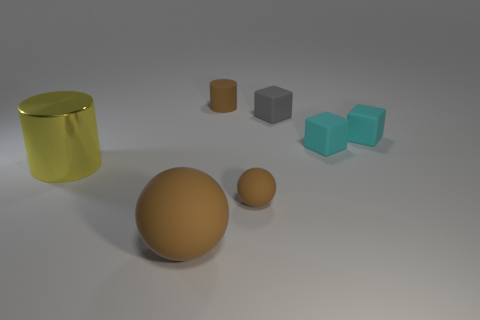Are the ball that is on the right side of the large brown ball and the tiny cylinder behind the tiny gray rubber block made of the same material?
Your answer should be very brief. Yes. There is a thing that is the same size as the shiny cylinder; what shape is it?
Give a very brief answer. Sphere. How many other objects are there of the same color as the large metal cylinder?
Your answer should be compact. 0. What color is the cylinder left of the small cylinder?
Provide a succinct answer. Yellow. What number of other things are the same material as the small gray thing?
Make the answer very short. 5. Is the number of matte spheres that are left of the small rubber sphere greater than the number of big objects to the left of the big yellow cylinder?
Offer a very short reply. Yes. How many large cylinders are on the left side of the tiny brown sphere?
Offer a terse response. 1. Is the material of the tiny ball the same as the tiny brown thing behind the gray matte cube?
Your answer should be very brief. Yes. Is the material of the gray cube the same as the large brown object?
Offer a very short reply. Yes. There is a big thing in front of the big yellow shiny thing; is there a big matte ball that is in front of it?
Your answer should be very brief. No. 